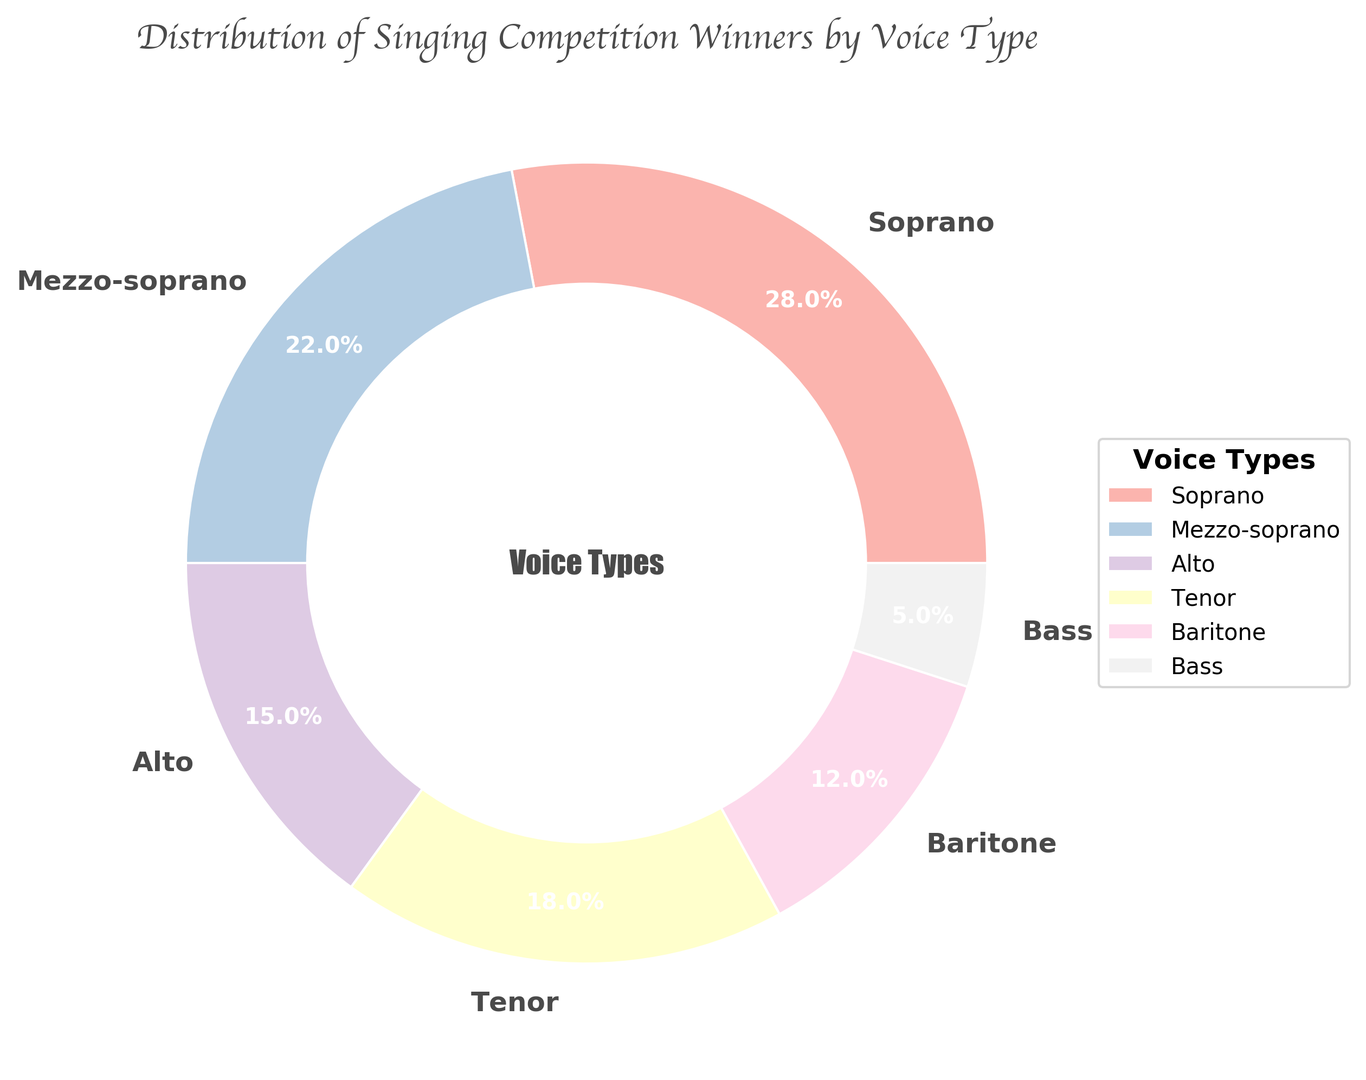What percentage of winners are Soprano and Alto combined? First, find the percentages of Soprano and Alto: Soprano is 28%, and Alto is 15%. Then, sum these values: 28% + 15% = 43%.
Answer: 43% Which voice type has the smallest percentage of winners? Look at the percentage values for each voice type and identify the smallest value. Bass has the smallest percentage at 5%.
Answer: Bass Are there more Tenor winners or Baritone winners? Compare the percentage values for Tenor and Baritone. Tenor has 18%, while Baritone has 12%. Tenor has a higher percentage.
Answer: Tenor What is the difference in percentage between the highest and lowest voice type? Identify the highest and lowest percentages: Soprano (28%) and Bass (5%), respectively. Then, subtract the smallest from the largest: 28% - 5% = 23%.
Answer: 23% What fraction of the total winners are either Mezzo-soprano or Baritone? Find the percentages for Mezzo-soprano (22%) and Baritone (12%). Add them together: 22% + 12% = 34%. Then, convert the percentage to a fraction: 34 / 100 = 34/100 or simplified, 17/50.
Answer: 17/50 Is the percentage of Tenor winners greater than the combined percentage of Alto and Bass? Find percentages for Tenor (18%), Alto (15%), and Bass (5%). Add Alto and Bass: 15% + 5% = 20%. Compare Tenor (18%) to the combined value (20%). 18% is less than 20%.
Answer: No How much larger is the Soprano percentage compared to the Mezzo-soprano percentage? Soprano has 28%, and Mezzo-soprano has 22%. Subtract Mezzo-soprano from Soprano: 28% - 22% = 6%.
Answer: 6% Which voice type occupies the second-largest section of the chart? By observing the percentage values, the second-largest value is Mezzo-soprano with 22%.
Answer: Mezzo-soprano 